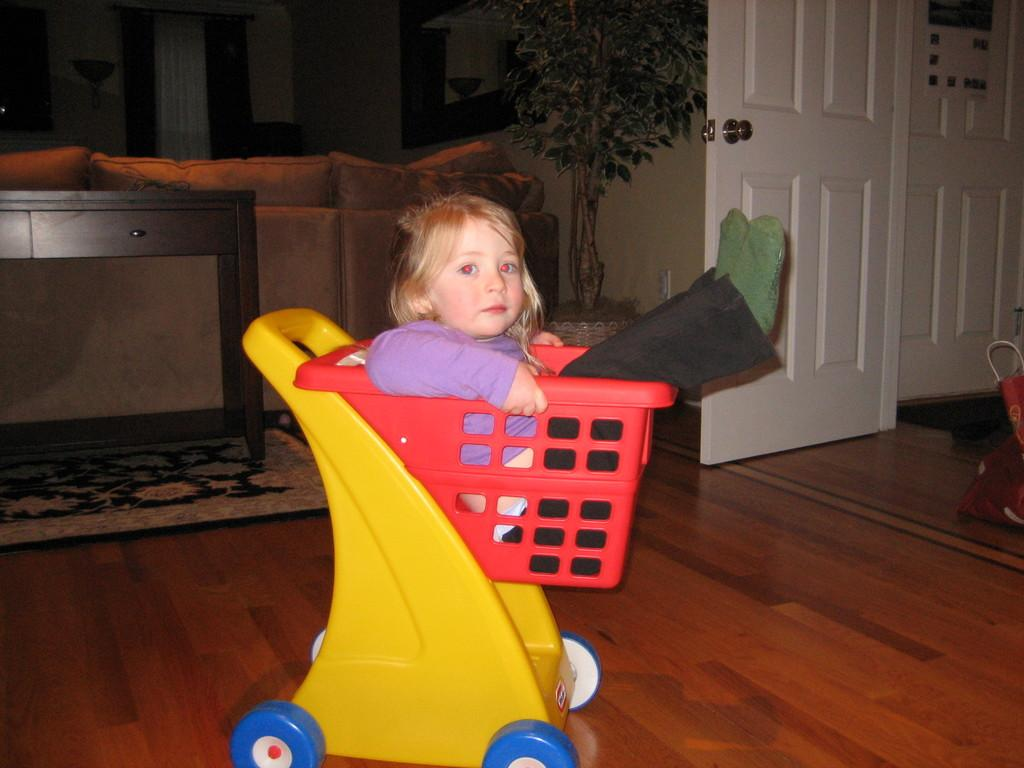What is the girl doing in the image? The girl is sitting in a toy basket. What objects can be seen in the background of the image? There is a table, a couch, a pillow, a plant, a door, and a carpet in the background. Can you describe the setting of the image? The image appears to be in a room with a table, couch, and other furniture, as well as a door leading to another area. What type of cabbage is the girl holding in the image? There is no cabbage present in the image; the girl is sitting in a toy basket. 